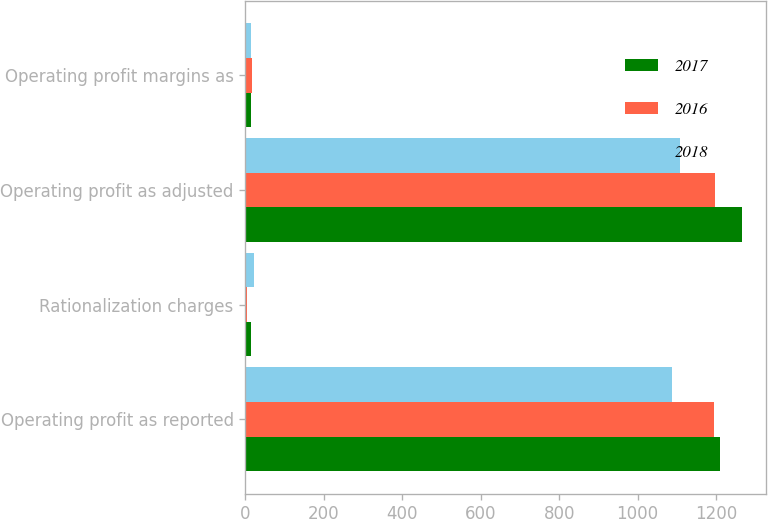<chart> <loc_0><loc_0><loc_500><loc_500><stacked_bar_chart><ecel><fcel>Operating profit as reported<fcel>Rationalization charges<fcel>Operating profit as adjusted<fcel>Operating profit margins as<nl><fcel>2017<fcel>1211<fcel>14<fcel>1265<fcel>15.1<nl><fcel>2016<fcel>1194<fcel>4<fcel>1198<fcel>15.7<nl><fcel>2018<fcel>1087<fcel>22<fcel>1109<fcel>15.1<nl></chart> 